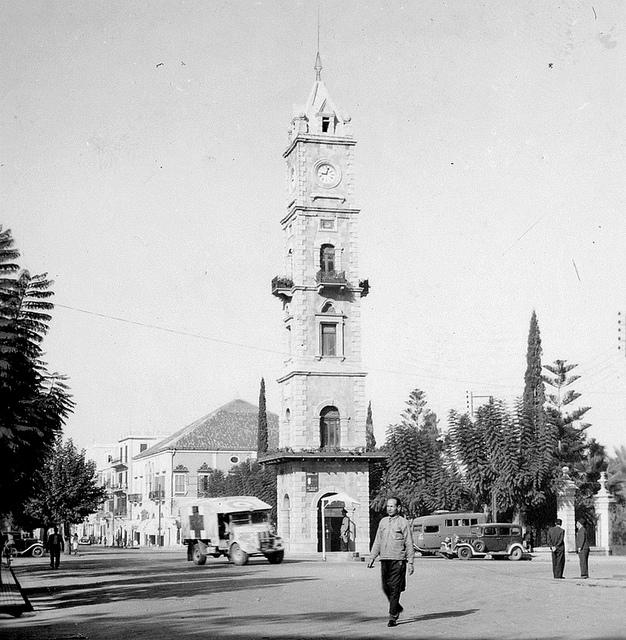How can you tell this photo is from the last century?
Write a very short answer. Cars are old. How many stories are in the center building?
Write a very short answer. 6. Is there a clock on the tower?
Keep it brief. Yes. When was the picture taken of the people and white antique car parked near the curb?
Write a very short answer. 1980. 